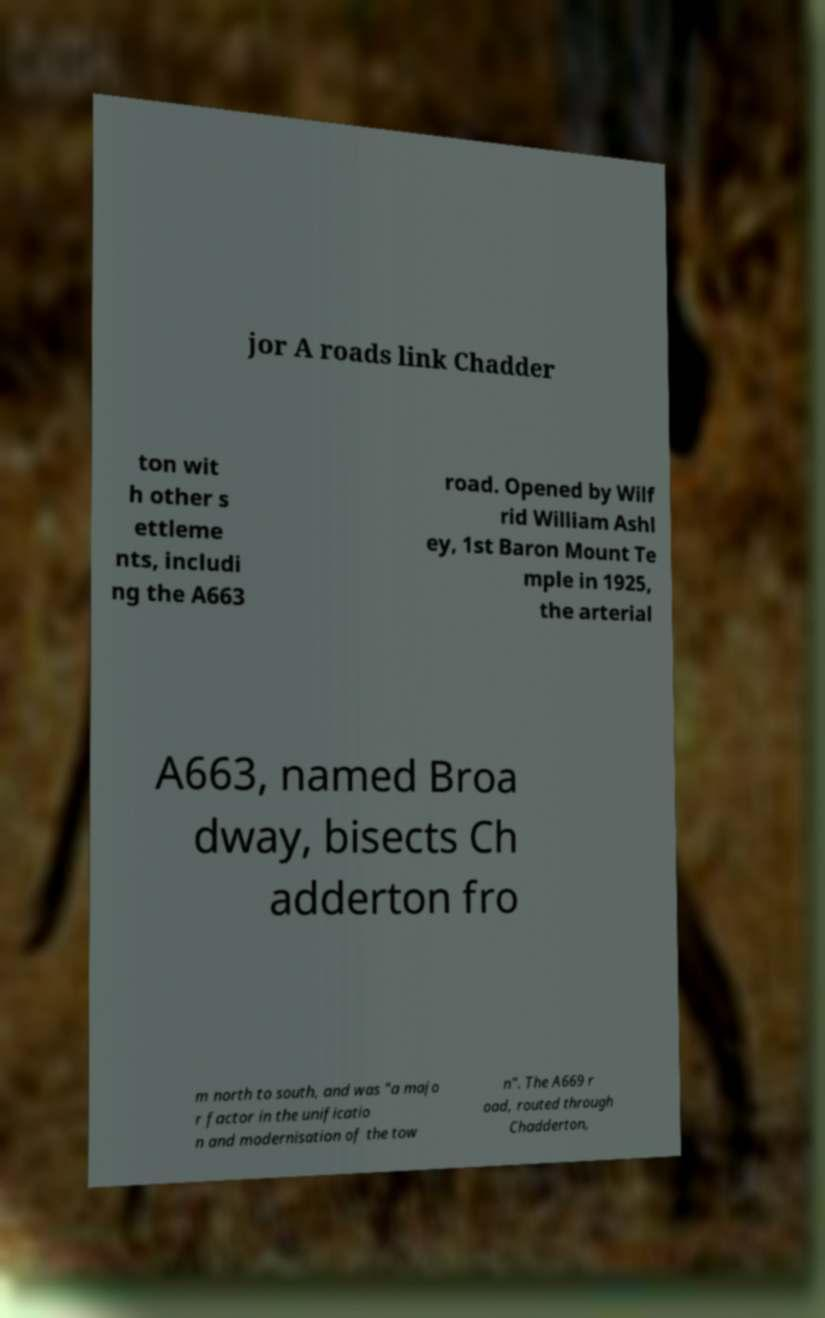Could you extract and type out the text from this image? jor A roads link Chadder ton wit h other s ettleme nts, includi ng the A663 road. Opened by Wilf rid William Ashl ey, 1st Baron Mount Te mple in 1925, the arterial A663, named Broa dway, bisects Ch adderton fro m north to south, and was "a majo r factor in the unificatio n and modernisation of the tow n". The A669 r oad, routed through Chadderton, 